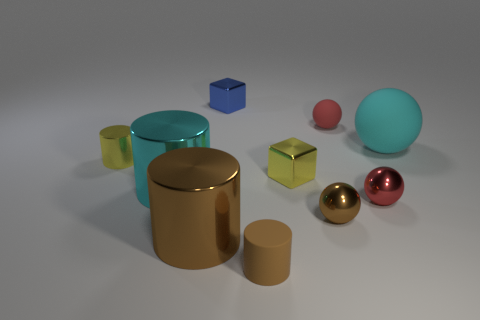Subtract all spheres. How many objects are left? 6 Add 4 brown balls. How many brown balls exist? 5 Subtract 0 yellow balls. How many objects are left? 10 Subtract all big metallic blocks. Subtract all large metallic things. How many objects are left? 8 Add 2 cyan metallic cylinders. How many cyan metallic cylinders are left? 3 